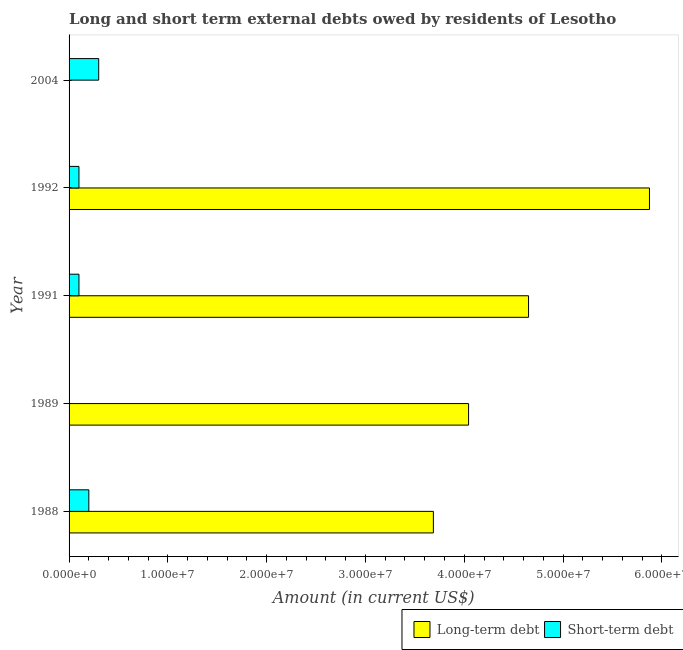How many different coloured bars are there?
Provide a short and direct response. 2. How many bars are there on the 3rd tick from the bottom?
Offer a terse response. 2. What is the label of the 2nd group of bars from the top?
Your answer should be very brief. 1992. What is the short-term debts owed by residents in 1989?
Ensure brevity in your answer.  0. Across all years, what is the maximum short-term debts owed by residents?
Provide a short and direct response. 3.00e+06. In which year was the short-term debts owed by residents maximum?
Provide a short and direct response. 2004. What is the total short-term debts owed by residents in the graph?
Provide a succinct answer. 7.00e+06. What is the difference between the long-term debts owed by residents in 1989 and that in 1992?
Your response must be concise. -1.83e+07. What is the difference between the short-term debts owed by residents in 2004 and the long-term debts owed by residents in 1992?
Your response must be concise. -5.57e+07. What is the average short-term debts owed by residents per year?
Your answer should be compact. 1.40e+06. In the year 1991, what is the difference between the long-term debts owed by residents and short-term debts owed by residents?
Provide a succinct answer. 4.55e+07. In how many years, is the short-term debts owed by residents greater than 8000000 US$?
Offer a terse response. 0. What is the ratio of the long-term debts owed by residents in 1989 to that in 1991?
Ensure brevity in your answer.  0.87. Is the long-term debts owed by residents in 1988 less than that in 1989?
Ensure brevity in your answer.  Yes. Is the difference between the short-term debts owed by residents in 1988 and 1992 greater than the difference between the long-term debts owed by residents in 1988 and 1992?
Give a very brief answer. Yes. What is the difference between the highest and the second highest long-term debts owed by residents?
Make the answer very short. 1.22e+07. What is the difference between the highest and the lowest short-term debts owed by residents?
Your answer should be very brief. 3.00e+06. Is the sum of the long-term debts owed by residents in 1988 and 1991 greater than the maximum short-term debts owed by residents across all years?
Give a very brief answer. Yes. Are all the bars in the graph horizontal?
Offer a terse response. Yes. What is the difference between two consecutive major ticks on the X-axis?
Offer a terse response. 1.00e+07. Are the values on the major ticks of X-axis written in scientific E-notation?
Give a very brief answer. Yes. Does the graph contain any zero values?
Your answer should be compact. Yes. Does the graph contain grids?
Offer a very short reply. No. Where does the legend appear in the graph?
Your response must be concise. Bottom right. How are the legend labels stacked?
Your answer should be very brief. Horizontal. What is the title of the graph?
Offer a very short reply. Long and short term external debts owed by residents of Lesotho. Does "Urban agglomerations" appear as one of the legend labels in the graph?
Your answer should be very brief. No. What is the label or title of the Y-axis?
Keep it short and to the point. Year. What is the Amount (in current US$) in Long-term debt in 1988?
Give a very brief answer. 3.69e+07. What is the Amount (in current US$) in Short-term debt in 1988?
Your response must be concise. 2.00e+06. What is the Amount (in current US$) in Long-term debt in 1989?
Your answer should be very brief. 4.04e+07. What is the Amount (in current US$) of Short-term debt in 1989?
Your response must be concise. 0. What is the Amount (in current US$) in Long-term debt in 1991?
Ensure brevity in your answer.  4.65e+07. What is the Amount (in current US$) in Short-term debt in 1991?
Your response must be concise. 1.00e+06. What is the Amount (in current US$) of Long-term debt in 1992?
Your response must be concise. 5.87e+07. What is the Amount (in current US$) of Long-term debt in 2004?
Offer a terse response. 0. Across all years, what is the maximum Amount (in current US$) of Long-term debt?
Your answer should be very brief. 5.87e+07. Across all years, what is the minimum Amount (in current US$) of Short-term debt?
Your response must be concise. 0. What is the total Amount (in current US$) of Long-term debt in the graph?
Ensure brevity in your answer.  1.83e+08. What is the difference between the Amount (in current US$) in Long-term debt in 1988 and that in 1989?
Make the answer very short. -3.56e+06. What is the difference between the Amount (in current US$) of Long-term debt in 1988 and that in 1991?
Provide a short and direct response. -9.63e+06. What is the difference between the Amount (in current US$) of Short-term debt in 1988 and that in 1991?
Ensure brevity in your answer.  1.00e+06. What is the difference between the Amount (in current US$) in Long-term debt in 1988 and that in 1992?
Your answer should be very brief. -2.19e+07. What is the difference between the Amount (in current US$) of Short-term debt in 1988 and that in 2004?
Offer a very short reply. -1.00e+06. What is the difference between the Amount (in current US$) of Long-term debt in 1989 and that in 1991?
Give a very brief answer. -6.07e+06. What is the difference between the Amount (in current US$) of Long-term debt in 1989 and that in 1992?
Provide a succinct answer. -1.83e+07. What is the difference between the Amount (in current US$) of Long-term debt in 1991 and that in 1992?
Your answer should be compact. -1.22e+07. What is the difference between the Amount (in current US$) of Short-term debt in 1991 and that in 1992?
Your answer should be very brief. 0. What is the difference between the Amount (in current US$) of Short-term debt in 1991 and that in 2004?
Your response must be concise. -2.00e+06. What is the difference between the Amount (in current US$) in Short-term debt in 1992 and that in 2004?
Ensure brevity in your answer.  -2.00e+06. What is the difference between the Amount (in current US$) of Long-term debt in 1988 and the Amount (in current US$) of Short-term debt in 1991?
Your answer should be very brief. 3.59e+07. What is the difference between the Amount (in current US$) of Long-term debt in 1988 and the Amount (in current US$) of Short-term debt in 1992?
Your answer should be very brief. 3.59e+07. What is the difference between the Amount (in current US$) of Long-term debt in 1988 and the Amount (in current US$) of Short-term debt in 2004?
Make the answer very short. 3.39e+07. What is the difference between the Amount (in current US$) of Long-term debt in 1989 and the Amount (in current US$) of Short-term debt in 1991?
Ensure brevity in your answer.  3.94e+07. What is the difference between the Amount (in current US$) of Long-term debt in 1989 and the Amount (in current US$) of Short-term debt in 1992?
Offer a very short reply. 3.94e+07. What is the difference between the Amount (in current US$) in Long-term debt in 1989 and the Amount (in current US$) in Short-term debt in 2004?
Make the answer very short. 3.74e+07. What is the difference between the Amount (in current US$) in Long-term debt in 1991 and the Amount (in current US$) in Short-term debt in 1992?
Keep it short and to the point. 4.55e+07. What is the difference between the Amount (in current US$) of Long-term debt in 1991 and the Amount (in current US$) of Short-term debt in 2004?
Your response must be concise. 4.35e+07. What is the difference between the Amount (in current US$) of Long-term debt in 1992 and the Amount (in current US$) of Short-term debt in 2004?
Keep it short and to the point. 5.57e+07. What is the average Amount (in current US$) of Long-term debt per year?
Your answer should be compact. 3.65e+07. What is the average Amount (in current US$) in Short-term debt per year?
Provide a short and direct response. 1.40e+06. In the year 1988, what is the difference between the Amount (in current US$) of Long-term debt and Amount (in current US$) of Short-term debt?
Provide a short and direct response. 3.49e+07. In the year 1991, what is the difference between the Amount (in current US$) in Long-term debt and Amount (in current US$) in Short-term debt?
Your answer should be very brief. 4.55e+07. In the year 1992, what is the difference between the Amount (in current US$) of Long-term debt and Amount (in current US$) of Short-term debt?
Give a very brief answer. 5.77e+07. What is the ratio of the Amount (in current US$) in Long-term debt in 1988 to that in 1989?
Offer a terse response. 0.91. What is the ratio of the Amount (in current US$) in Long-term debt in 1988 to that in 1991?
Make the answer very short. 0.79. What is the ratio of the Amount (in current US$) in Short-term debt in 1988 to that in 1991?
Your answer should be compact. 2. What is the ratio of the Amount (in current US$) in Long-term debt in 1988 to that in 1992?
Offer a terse response. 0.63. What is the ratio of the Amount (in current US$) in Short-term debt in 1988 to that in 1992?
Offer a terse response. 2. What is the ratio of the Amount (in current US$) in Long-term debt in 1989 to that in 1991?
Make the answer very short. 0.87. What is the ratio of the Amount (in current US$) in Long-term debt in 1989 to that in 1992?
Give a very brief answer. 0.69. What is the ratio of the Amount (in current US$) in Long-term debt in 1991 to that in 1992?
Offer a terse response. 0.79. What is the ratio of the Amount (in current US$) of Short-term debt in 1992 to that in 2004?
Give a very brief answer. 0.33. What is the difference between the highest and the second highest Amount (in current US$) in Long-term debt?
Offer a terse response. 1.22e+07. What is the difference between the highest and the lowest Amount (in current US$) of Long-term debt?
Your response must be concise. 5.87e+07. What is the difference between the highest and the lowest Amount (in current US$) of Short-term debt?
Keep it short and to the point. 3.00e+06. 